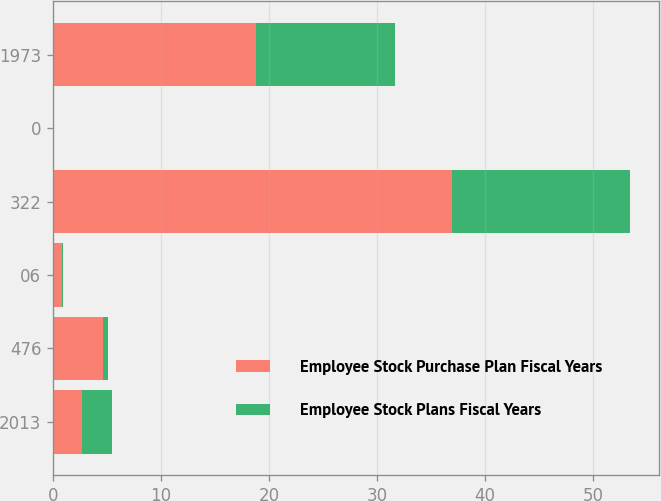<chart> <loc_0><loc_0><loc_500><loc_500><stacked_bar_chart><ecel><fcel>2013<fcel>476<fcel>06<fcel>322<fcel>0<fcel>1973<nl><fcel>Employee Stock Purchase Plan Fiscal Years<fcel>2.72<fcel>4.64<fcel>0.8<fcel>36.9<fcel>0<fcel>18.75<nl><fcel>Employee Stock Plans Fiscal Years<fcel>2.72<fcel>0.5<fcel>0.1<fcel>16.5<fcel>0<fcel>12.95<nl></chart> 